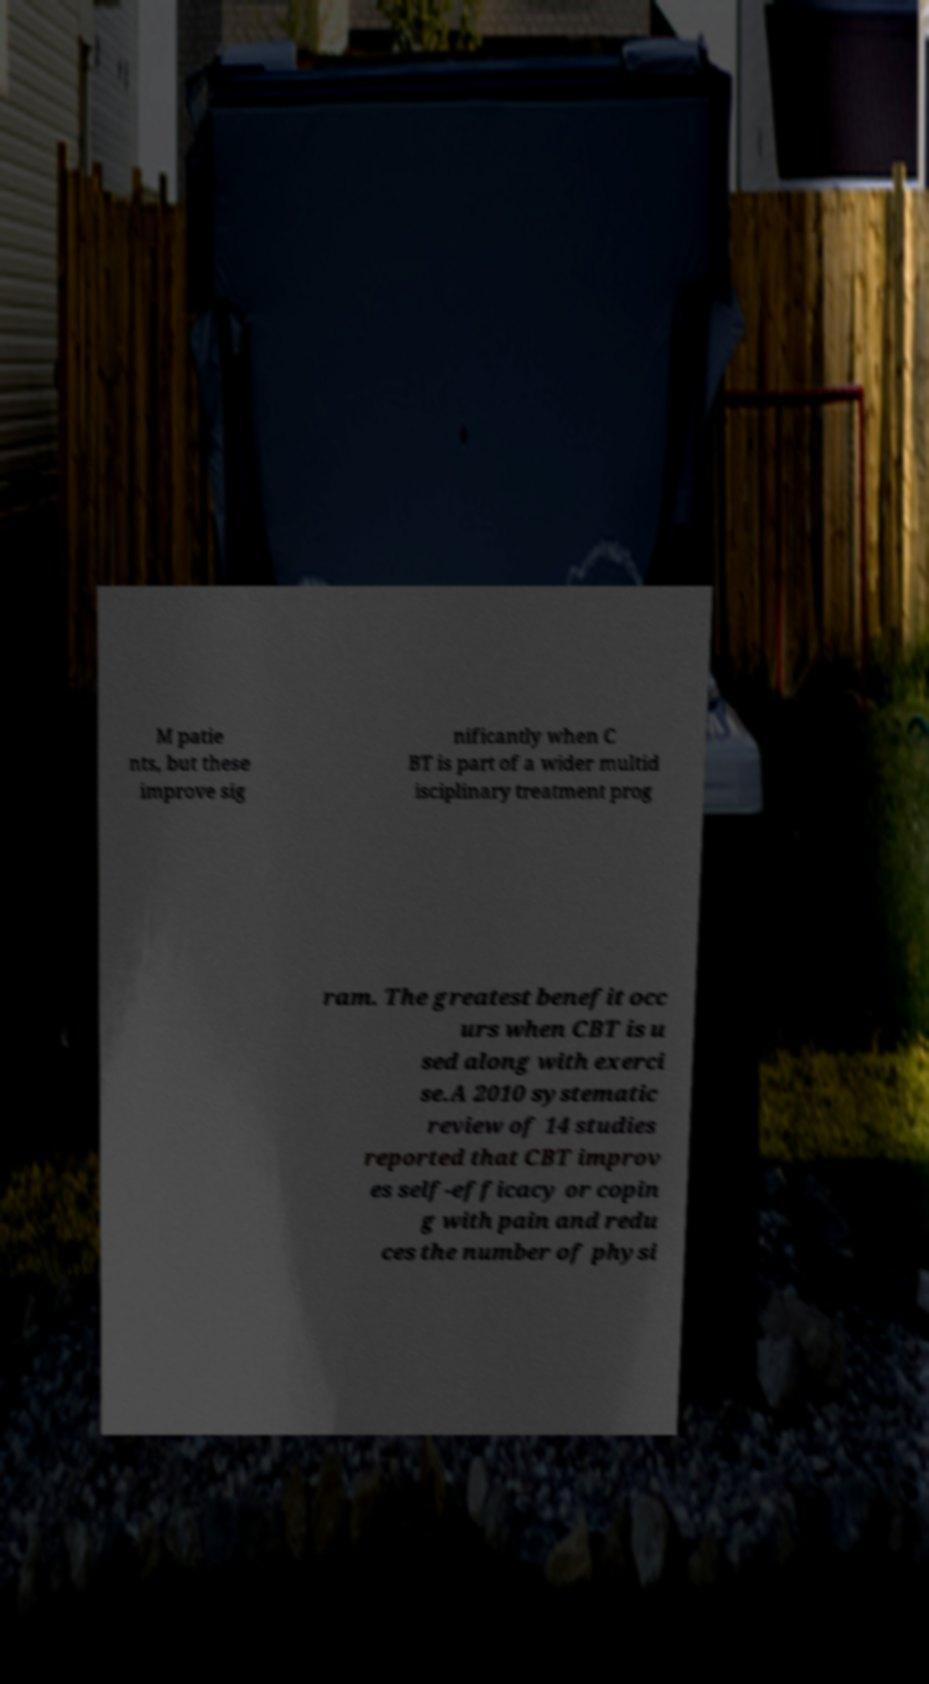Could you assist in decoding the text presented in this image and type it out clearly? M patie nts, but these improve sig nificantly when C BT is part of a wider multid isciplinary treatment prog ram. The greatest benefit occ urs when CBT is u sed along with exerci se.A 2010 systematic review of 14 studies reported that CBT improv es self-efficacy or copin g with pain and redu ces the number of physi 